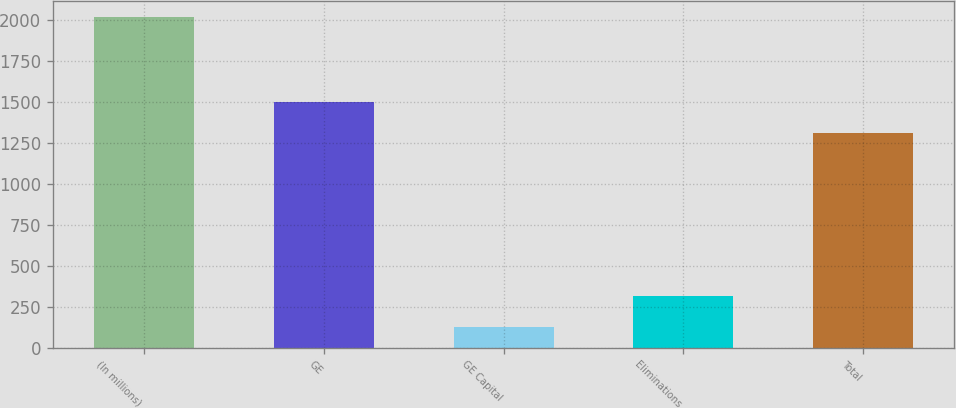<chart> <loc_0><loc_0><loc_500><loc_500><bar_chart><fcel>(In millions)<fcel>GE<fcel>GE Capital<fcel>Eliminations<fcel>Total<nl><fcel>2013<fcel>1494.9<fcel>124<fcel>312.9<fcel>1306<nl></chart> 